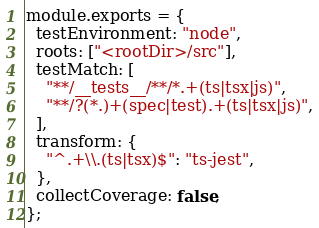<code> <loc_0><loc_0><loc_500><loc_500><_JavaScript_>module.exports = {
  testEnvironment: "node",
  roots: ["<rootDir>/src"],
  testMatch: [
    "**/__tests__/**/*.+(ts|tsx|js)",
    "**/?(*.)+(spec|test).+(ts|tsx|js)",
  ],
  transform: {
    "^.+\\.(ts|tsx)$": "ts-jest",
  },
  collectCoverage: false,
};
</code> 